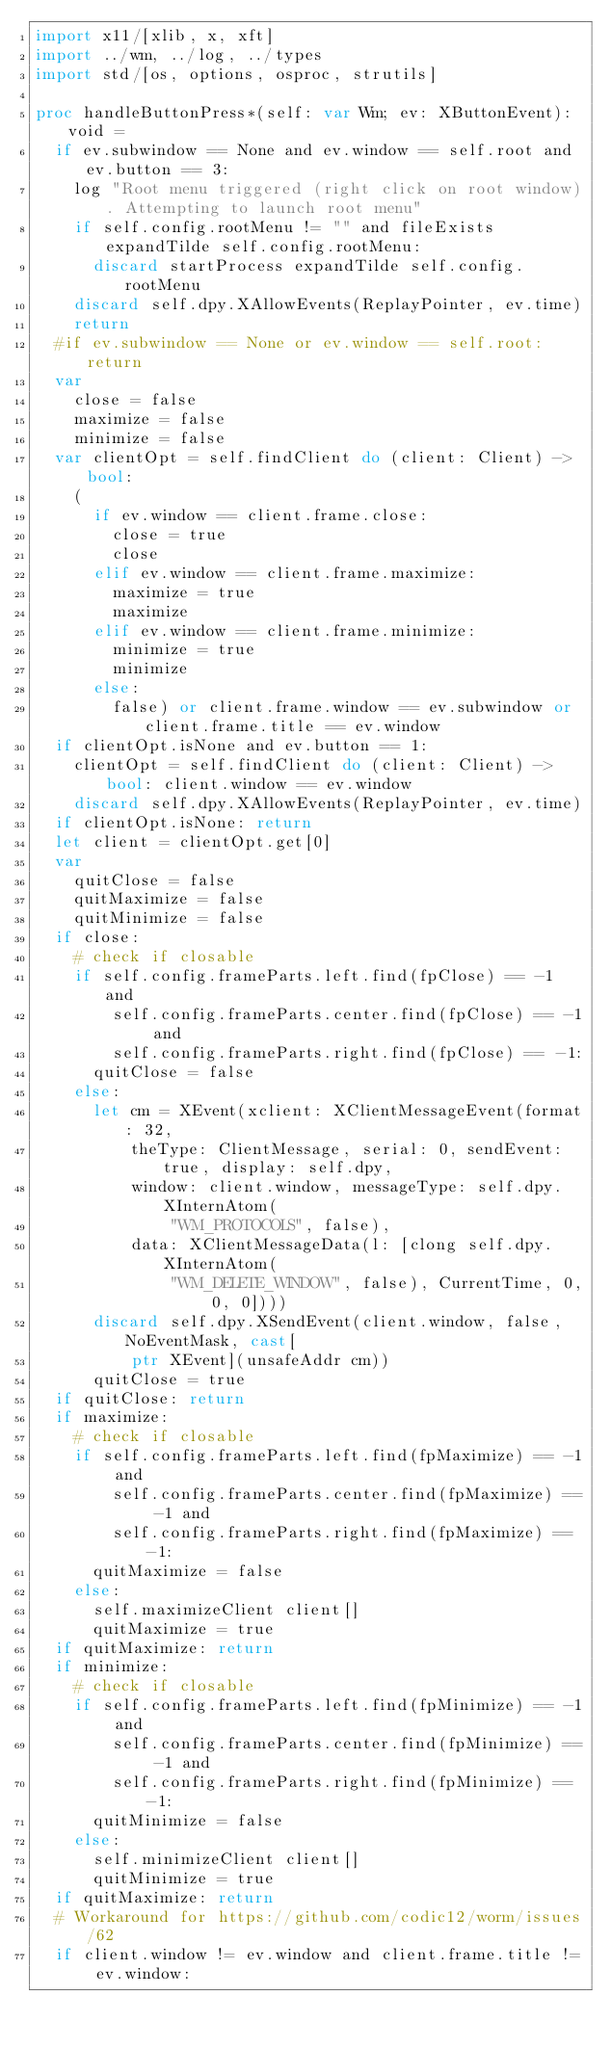<code> <loc_0><loc_0><loc_500><loc_500><_Nim_>import x11/[xlib, x, xft]
import ../wm, ../log, ../types
import std/[os, options, osproc, strutils]

proc handleButtonPress*(self: var Wm; ev: XButtonEvent): void =
  if ev.subwindow == None and ev.window == self.root and ev.button == 3:
    log "Root menu triggered (right click on root window). Attempting to launch root menu"
    if self.config.rootMenu != "" and fileExists expandTilde self.config.rootMenu:
      discard startProcess expandTilde self.config.rootMenu
    discard self.dpy.XAllowEvents(ReplayPointer, ev.time)
    return
  #if ev.subwindow == None or ev.window == self.root: return
  var
    close = false
    maximize = false
    minimize = false
  var clientOpt = self.findClient do (client: Client) -> bool:
    (
      if ev.window == client.frame.close:
        close = true
        close
      elif ev.window == client.frame.maximize:
        maximize = true
        maximize
      elif ev.window == client.frame.minimize:
        minimize = true
        minimize
      else:
        false) or client.frame.window == ev.subwindow or client.frame.title == ev.window
  if clientOpt.isNone and ev.button == 1:
    clientOpt = self.findClient do (client: Client) -> bool: client.window == ev.window
    discard self.dpy.XAllowEvents(ReplayPointer, ev.time)
  if clientOpt.isNone: return
  let client = clientOpt.get[0]
  var 
    quitClose = false
    quitMaximize = false
    quitMinimize = false
  if close:
    # check if closable
    if self.config.frameParts.left.find(fpClose) == -1 and
        self.config.frameParts.center.find(fpClose) == -1 and
        self.config.frameParts.right.find(fpClose) == -1:
      quitClose = false
    else:
      let cm = XEvent(xclient: XClientMessageEvent(format: 32,
          theType: ClientMessage, serial: 0, sendEvent: true, display: self.dpy,
          window: client.window, messageType: self.dpy.XInternAtom(
              "WM_PROTOCOLS", false),
          data: XClientMessageData(l: [clong self.dpy.XInternAtom(
              "WM_DELETE_WINDOW", false), CurrentTime, 0, 0, 0])))
      discard self.dpy.XSendEvent(client.window, false, NoEventMask, cast[
          ptr XEvent](unsafeAddr cm))
      quitClose = true
  if quitClose: return
  if maximize:
    # check if closable
    if self.config.frameParts.left.find(fpMaximize) == -1 and
        self.config.frameParts.center.find(fpMaximize) == -1 and
        self.config.frameParts.right.find(fpMaximize) == -1:
      quitMaximize = false
    else:
      self.maximizeClient client[]
      quitMaximize = true
  if quitMaximize: return
  if minimize:
    # check if closable
    if self.config.frameParts.left.find(fpMinimize) == -1 and
        self.config.frameParts.center.find(fpMinimize) == -1 and
        self.config.frameParts.right.find(fpMinimize) == -1:
      quitMinimize = false
    else:
      self.minimizeClient client[]
      quitMinimize = true
  if quitMaximize: return
  # Workaround for https://github.com/codic12/worm/issues/62
  if client.window != ev.window and client.frame.title != ev.window:</code> 